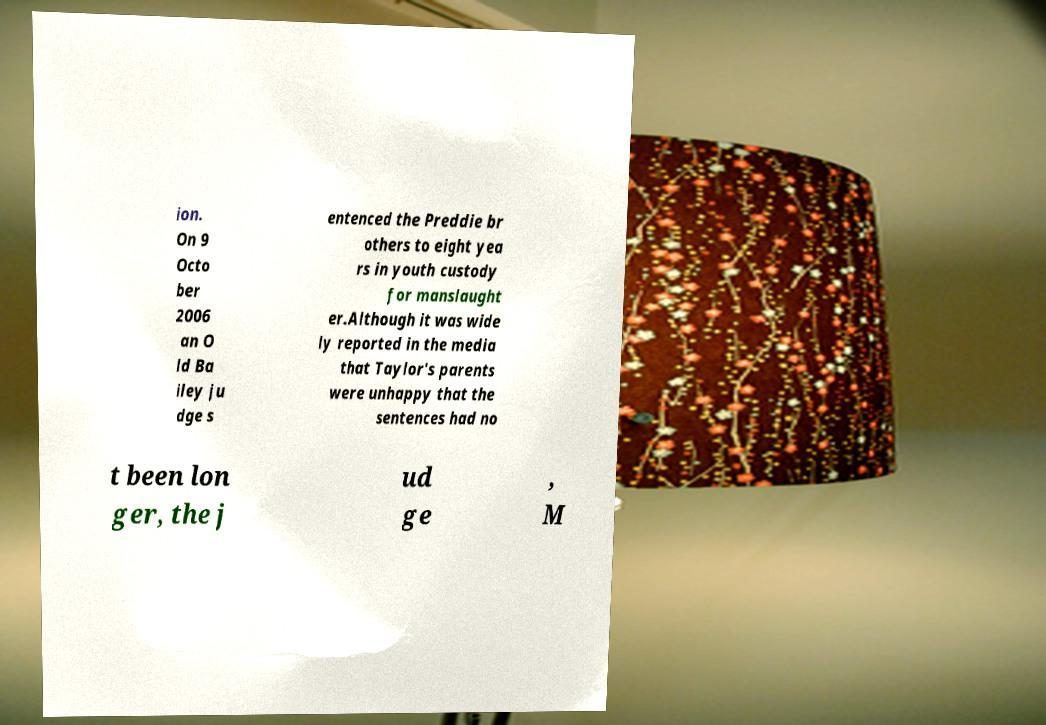Can you accurately transcribe the text from the provided image for me? ion. On 9 Octo ber 2006 an O ld Ba iley ju dge s entenced the Preddie br others to eight yea rs in youth custody for manslaught er.Although it was wide ly reported in the media that Taylor's parents were unhappy that the sentences had no t been lon ger, the j ud ge , M 